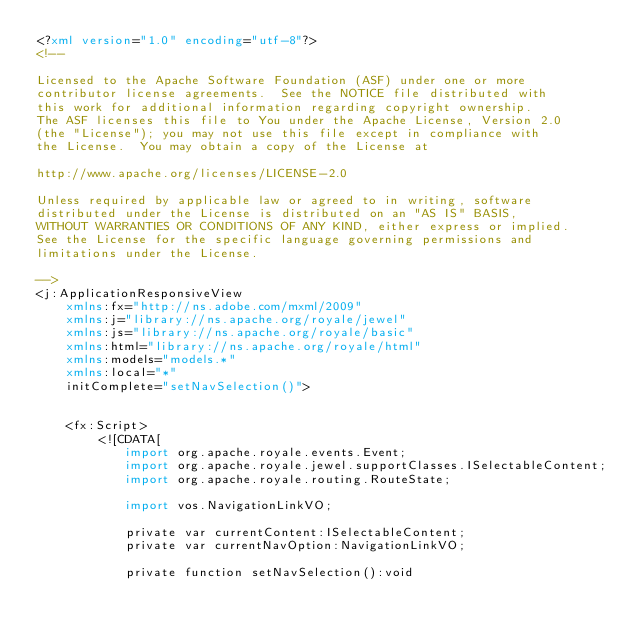Convert code to text. <code><loc_0><loc_0><loc_500><loc_500><_XML_><?xml version="1.0" encoding="utf-8"?>
<!--

Licensed to the Apache Software Foundation (ASF) under one or more
contributor license agreements.  See the NOTICE file distributed with
this work for additional information regarding copyright ownership.
The ASF licenses this file to You under the Apache License, Version 2.0
(the "License"); you may not use this file except in compliance with
the License.  You may obtain a copy of the License at

http://www.apache.org/licenses/LICENSE-2.0

Unless required by applicable law or agreed to in writing, software
distributed under the License is distributed on an "AS IS" BASIS,
WITHOUT WARRANTIES OR CONDITIONS OF ANY KIND, either express or implied.
See the License for the specific language governing permissions and
limitations under the License.

-->
<j:ApplicationResponsiveView
    xmlns:fx="http://ns.adobe.com/mxml/2009"
    xmlns:j="library://ns.apache.org/royale/jewel"
    xmlns:js="library://ns.apache.org/royale/basic"
    xmlns:html="library://ns.apache.org/royale/html"
    xmlns:models="models.*"
    xmlns:local="*"
    initComplete="setNavSelection()">


    <fx:Script>
        <![CDATA[
            import org.apache.royale.events.Event;
            import org.apache.royale.jewel.supportClasses.ISelectableContent;
            import org.apache.royale.routing.RouteState;

            import vos.NavigationLinkVO;

            private var currentContent:ISelectableContent;
            private var currentNavOption:NavigationLinkVO;
            
            private function setNavSelection():void</code> 